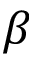<formula> <loc_0><loc_0><loc_500><loc_500>\beta</formula> 